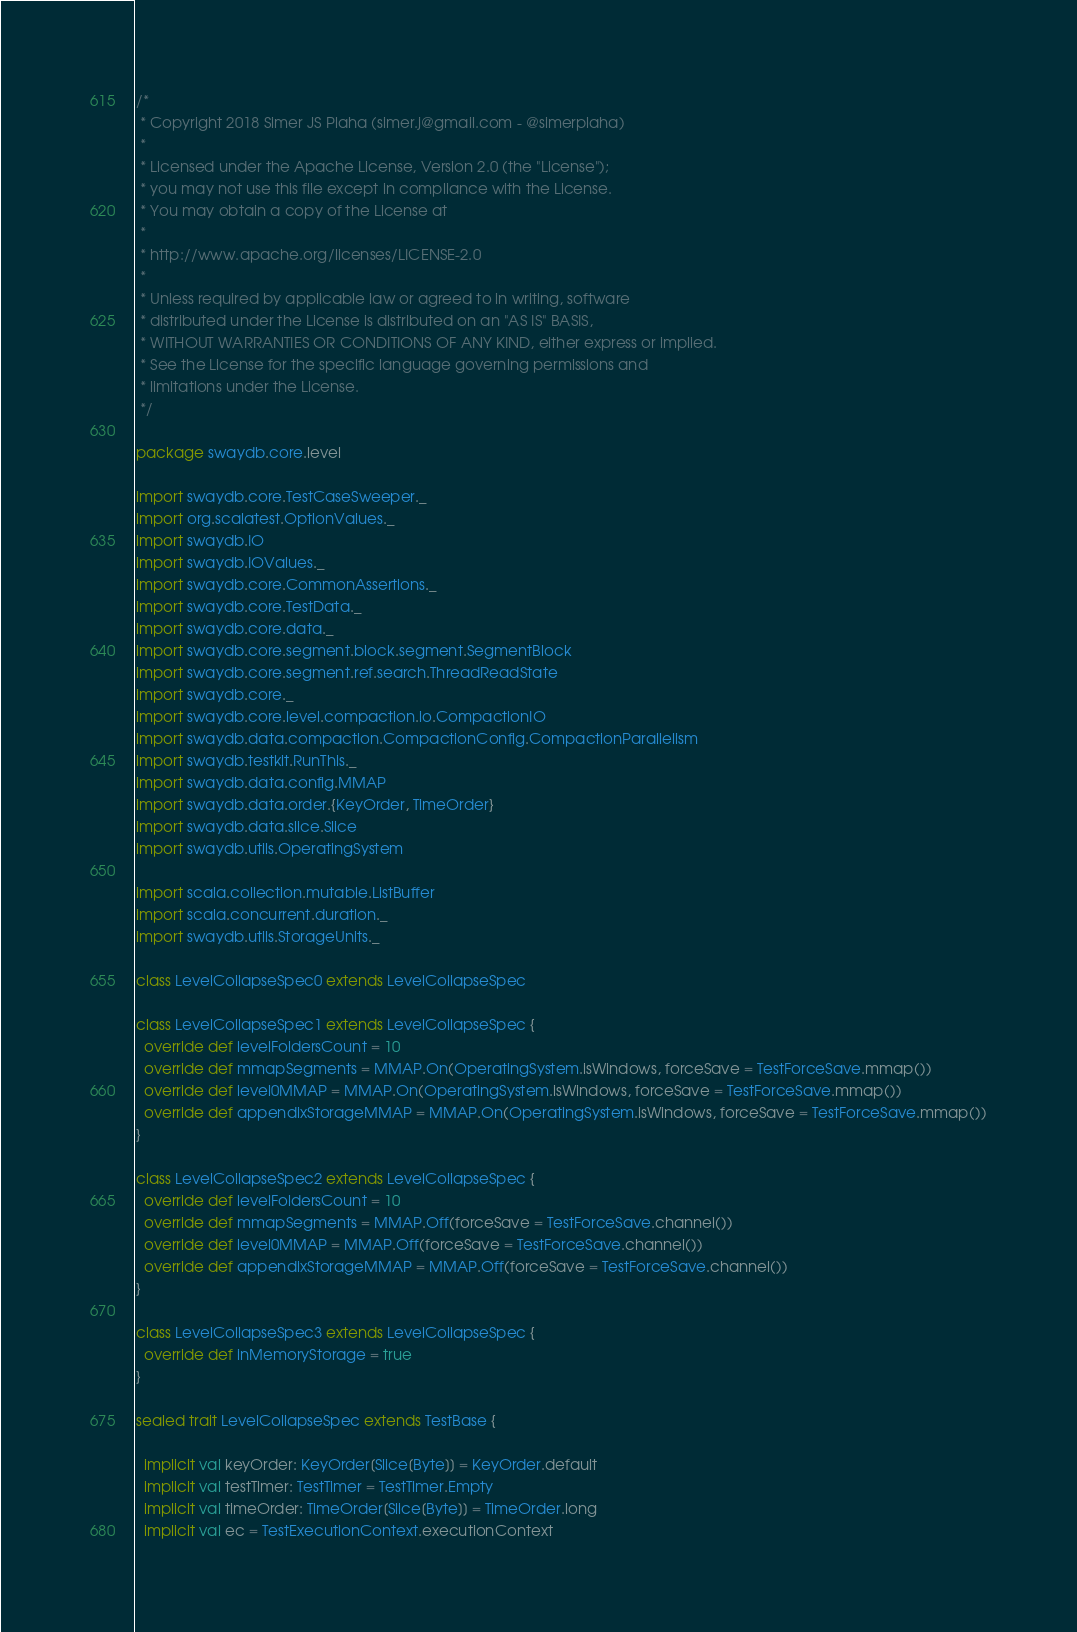Convert code to text. <code><loc_0><loc_0><loc_500><loc_500><_Scala_>/*
 * Copyright 2018 Simer JS Plaha (simer.j@gmail.com - @simerplaha)
 *
 * Licensed under the Apache License, Version 2.0 (the "License");
 * you may not use this file except in compliance with the License.
 * You may obtain a copy of the License at
 *
 * http://www.apache.org/licenses/LICENSE-2.0
 *
 * Unless required by applicable law or agreed to in writing, software
 * distributed under the License is distributed on an "AS IS" BASIS,
 * WITHOUT WARRANTIES OR CONDITIONS OF ANY KIND, either express or implied.
 * See the License for the specific language governing permissions and
 * limitations under the License.
 */

package swaydb.core.level

import swaydb.core.TestCaseSweeper._
import org.scalatest.OptionValues._
import swaydb.IO
import swaydb.IOValues._
import swaydb.core.CommonAssertions._
import swaydb.core.TestData._
import swaydb.core.data._
import swaydb.core.segment.block.segment.SegmentBlock
import swaydb.core.segment.ref.search.ThreadReadState
import swaydb.core._
import swaydb.core.level.compaction.io.CompactionIO
import swaydb.data.compaction.CompactionConfig.CompactionParallelism
import swaydb.testkit.RunThis._
import swaydb.data.config.MMAP
import swaydb.data.order.{KeyOrder, TimeOrder}
import swaydb.data.slice.Slice
import swaydb.utils.OperatingSystem

import scala.collection.mutable.ListBuffer
import scala.concurrent.duration._
import swaydb.utils.StorageUnits._

class LevelCollapseSpec0 extends LevelCollapseSpec

class LevelCollapseSpec1 extends LevelCollapseSpec {
  override def levelFoldersCount = 10
  override def mmapSegments = MMAP.On(OperatingSystem.isWindows, forceSave = TestForceSave.mmap())
  override def level0MMAP = MMAP.On(OperatingSystem.isWindows, forceSave = TestForceSave.mmap())
  override def appendixStorageMMAP = MMAP.On(OperatingSystem.isWindows, forceSave = TestForceSave.mmap())
}

class LevelCollapseSpec2 extends LevelCollapseSpec {
  override def levelFoldersCount = 10
  override def mmapSegments = MMAP.Off(forceSave = TestForceSave.channel())
  override def level0MMAP = MMAP.Off(forceSave = TestForceSave.channel())
  override def appendixStorageMMAP = MMAP.Off(forceSave = TestForceSave.channel())
}

class LevelCollapseSpec3 extends LevelCollapseSpec {
  override def inMemoryStorage = true
}

sealed trait LevelCollapseSpec extends TestBase {

  implicit val keyOrder: KeyOrder[Slice[Byte]] = KeyOrder.default
  implicit val testTimer: TestTimer = TestTimer.Empty
  implicit val timeOrder: TimeOrder[Slice[Byte]] = TimeOrder.long
  implicit val ec = TestExecutionContext.executionContext</code> 